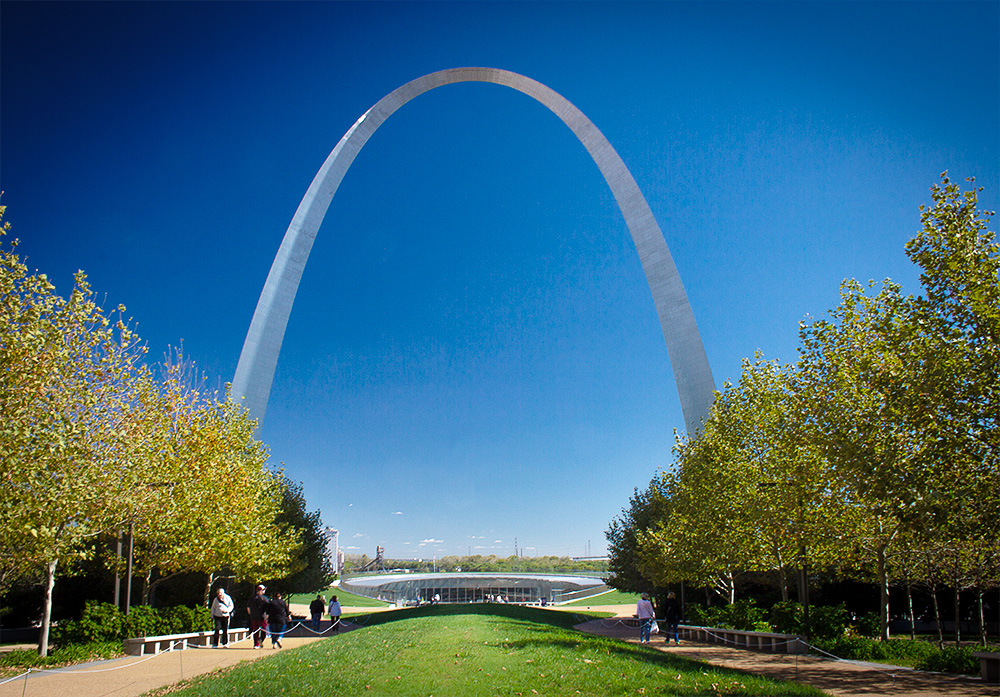What makes this landmark historically significant? The Gateway Arch is historically significant as it commemorates the westward expansion of the United States. Built as a monument to Thomas Jefferson's vision of the westward movement, the arch stands as a symbol of the pioneering spirit and the nation's growth. Designed by architect Eero Saarinen and completed in 1965, it serves not only as a historical marker but also as an architectural marvel showcasing innovative engineering and design. Describe a scenario where this image might be part of a movie scene. In an epic adventure film, the Gateway Arch stands tall in the background as the protagonist embarks on a quest that begins in the heart of St. Louis. The arch symbolizes a gateway to new adventures and unknown territories. As the sun sets, casting a golden hue over the monument, the protagonist reflects on the challenges ahead, inspired by the arch's towering presence and the historical legacy it represents. This scene sets the tone for a journey filled with exploration, courage, and discovery. 